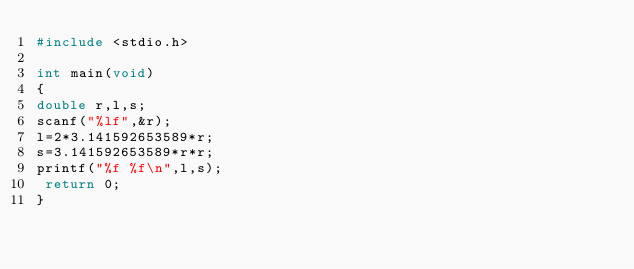<code> <loc_0><loc_0><loc_500><loc_500><_C_>#include <stdio.h>

int main(void)
{
double r,l,s;
scanf("%lf",&r);
l=2*3.141592653589*r;
s=3.141592653589*r*r;
printf("%f %f\n",l,s);
 return 0;
}</code> 